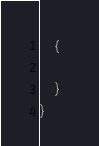<code> <loc_0><loc_0><loc_500><loc_500><_C#_>    {
        
    }
}</code> 